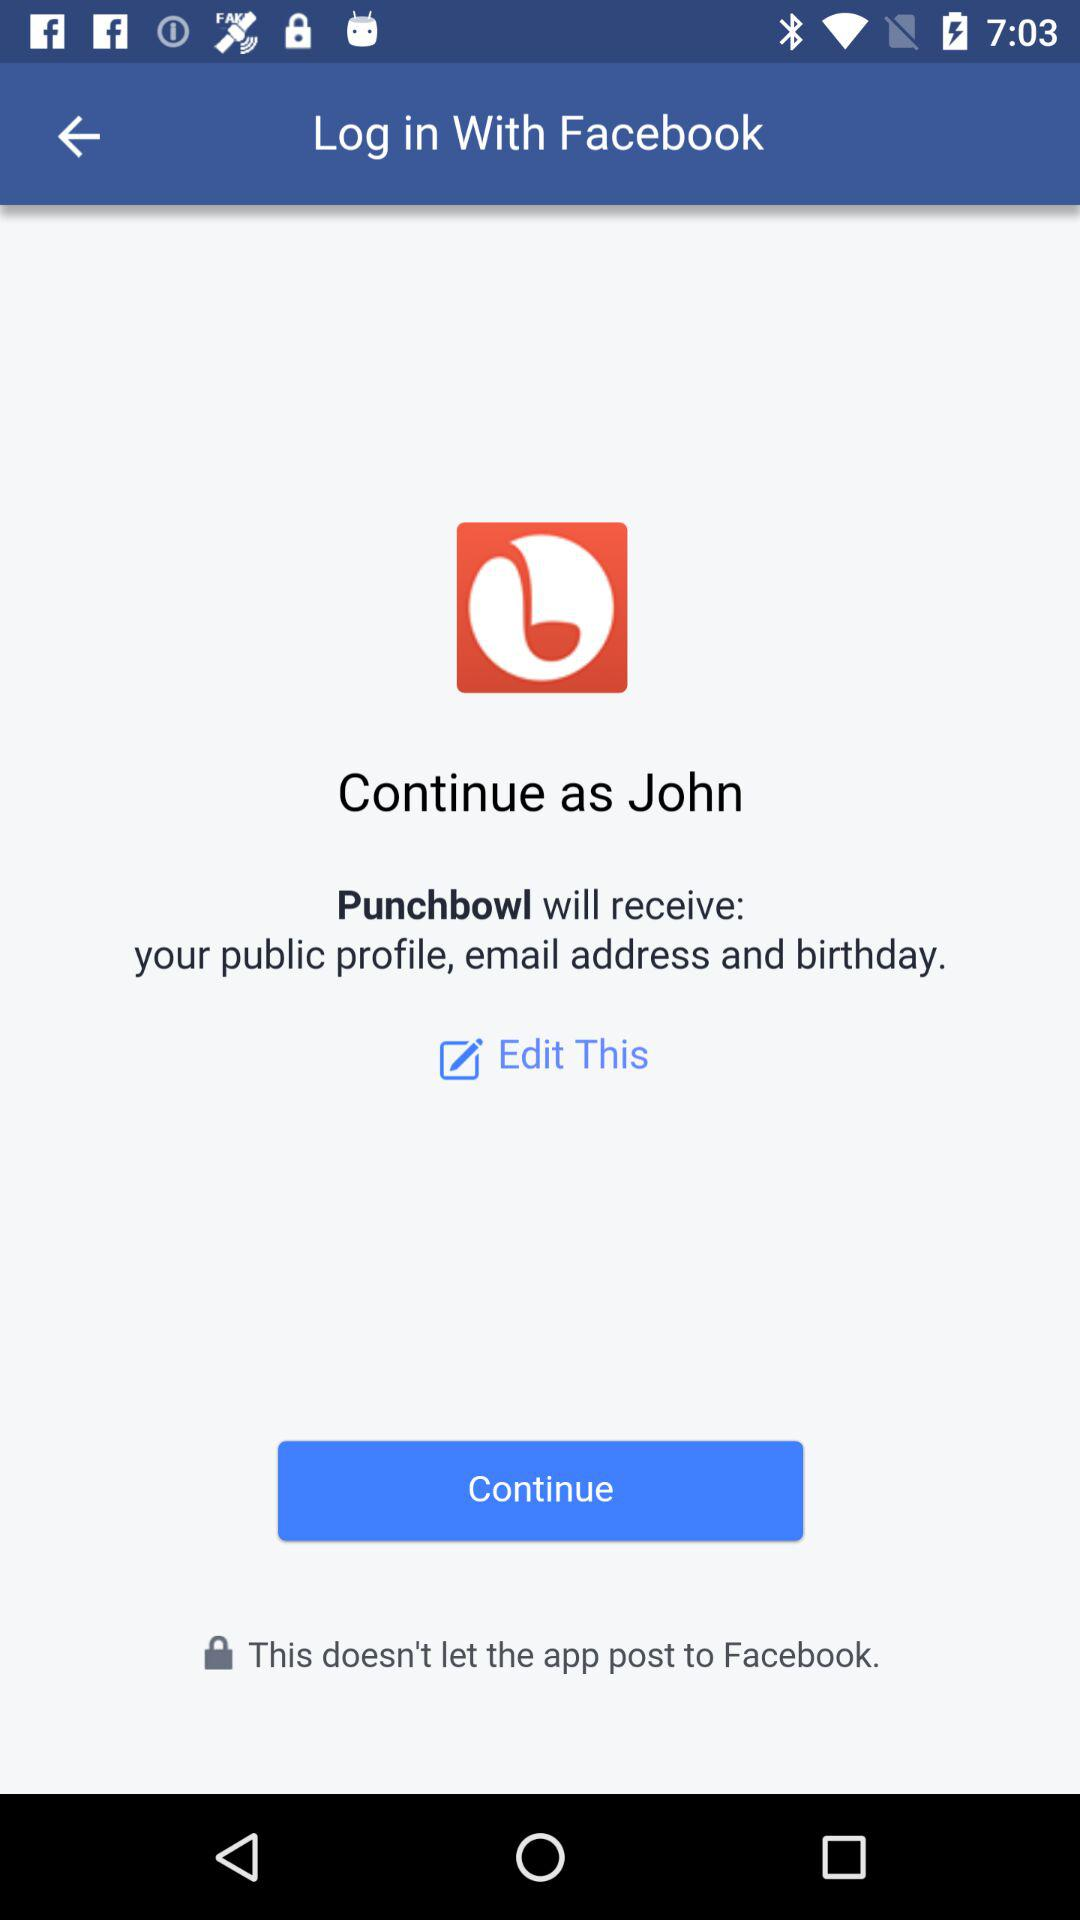What application is asking for permission? The application that is asking for permission is "Punchbowl". 